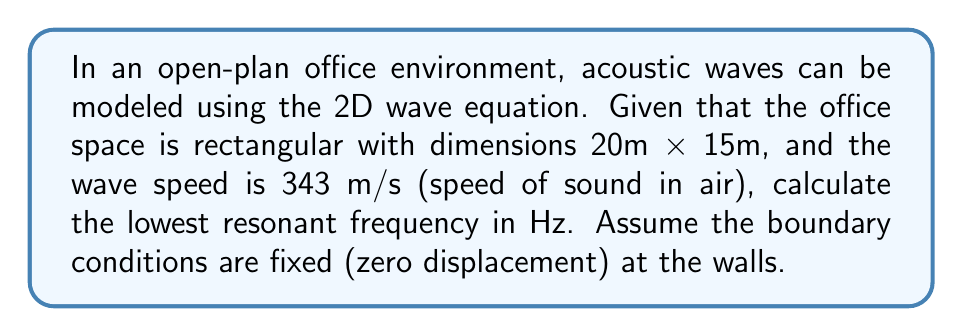Could you help me with this problem? To solve this problem, we'll follow these steps:

1) The 2D wave equation is given by:

   $$\frac{\partial^2 u}{\partial t^2} = c^2 \left(\frac{\partial^2 u}{\partial x^2} + \frac{\partial^2 u}{\partial y^2}\right)$$

   where $c$ is the wave speed.

2) For a rectangular domain with fixed boundaries, the solution takes the form:

   $$u(x,y,t) = \sin(\frac{n\pi x}{L_x})\sin(\frac{m\pi y}{L_y})\cos(\omega t)$$

   where $L_x$ and $L_y$ are the dimensions of the rectangle, and $n$ and $m$ are positive integers.

3) The angular frequency $\omega$ is related to the wave speed $c$ by:

   $$\omega^2 = c^2\left(\frac{n^2\pi^2}{L_x^2} + \frac{m^2\pi^2}{L_y^2}\right)$$

4) The lowest resonant frequency corresponds to $n=1$ and $m=1$. So:

   $$\omega^2 = c^2\pi^2\left(\frac{1}{L_x^2} + \frac{1}{L_y^2}\right)$$

5) Substituting the given values:
   $c = 343$ m/s, $L_x = 20$ m, $L_y = 15$ m

   $$\omega^2 = (343)^2\pi^2\left(\frac{1}{20^2} + \frac{1}{15^2}\right)$$

6) Simplify:
   $$\omega^2 = 117649\pi^2\left(\frac{1}{400} + \frac{1}{225}\right) = 117649\pi^2\left(\frac{9}{3600} + \frac{16}{3600}\right) = 117649\pi^2\left(\frac{25}{3600}\right)$$

7) Calculate $\omega$:
   $$\omega = \sqrt{117649\pi^2\left(\frac{25}{3600}\right)} \approx 15.0396$$

8) Convert angular frequency to Hz:
   $$f = \frac{\omega}{2\pi} \approx 2.3940$$ Hz
Answer: 2.39 Hz 